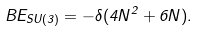Convert formula to latex. <formula><loc_0><loc_0><loc_500><loc_500>B E _ { S U ( 3 ) } = - \delta ( 4 N ^ { 2 } + 6 N ) .</formula> 